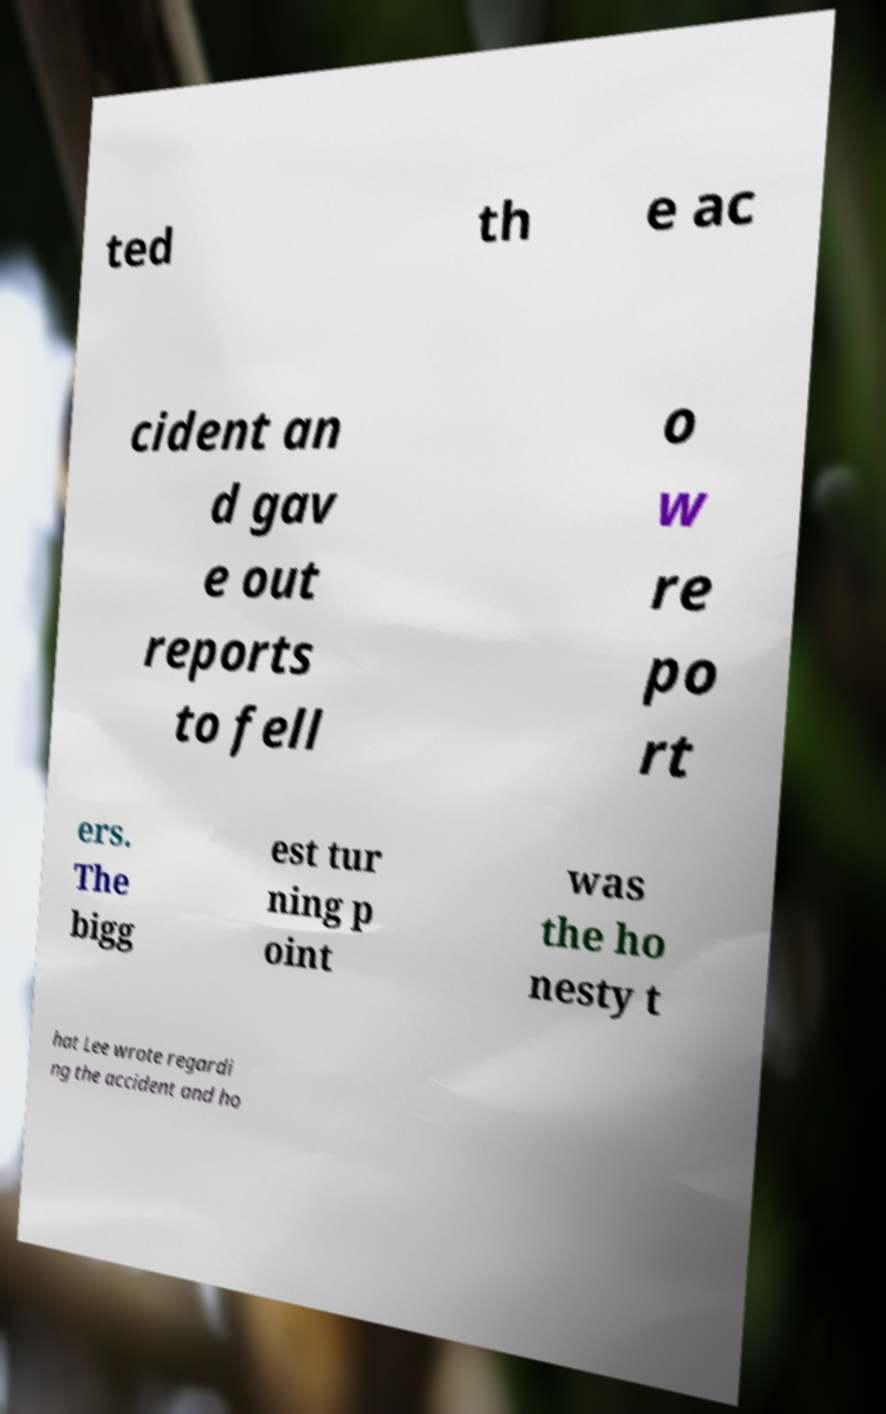I need the written content from this picture converted into text. Can you do that? ted th e ac cident an d gav e out reports to fell o w re po rt ers. The bigg est tur ning p oint was the ho nesty t hat Lee wrote regardi ng the accident and ho 